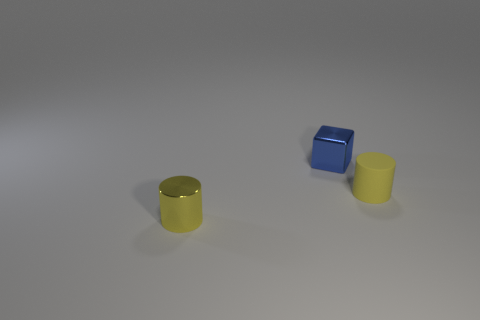Add 1 small yellow cylinders. How many objects exist? 4 Subtract all cubes. How many objects are left? 2 Subtract 1 cubes. How many cubes are left? 0 Subtract all cyan cylinders. How many gray blocks are left? 0 Add 2 small blue blocks. How many small blue blocks are left? 3 Add 2 small yellow metallic cylinders. How many small yellow metallic cylinders exist? 3 Subtract 0 cyan cylinders. How many objects are left? 3 Subtract all brown cylinders. Subtract all red balls. How many cylinders are left? 2 Subtract all large green spheres. Subtract all yellow metal cylinders. How many objects are left? 2 